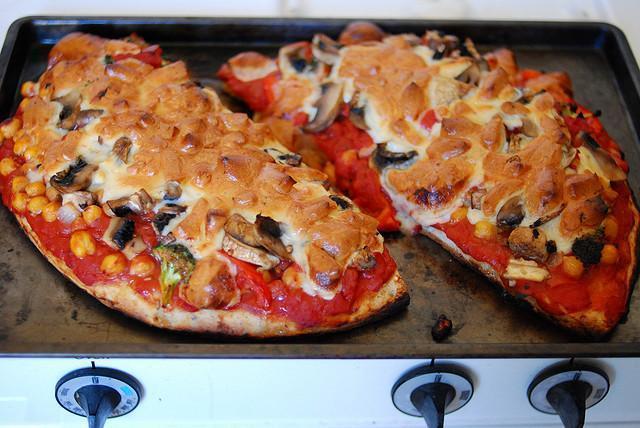How many slices is the pizza cut into?
Give a very brief answer. 2. How many pizzas can you see?
Give a very brief answer. 2. 